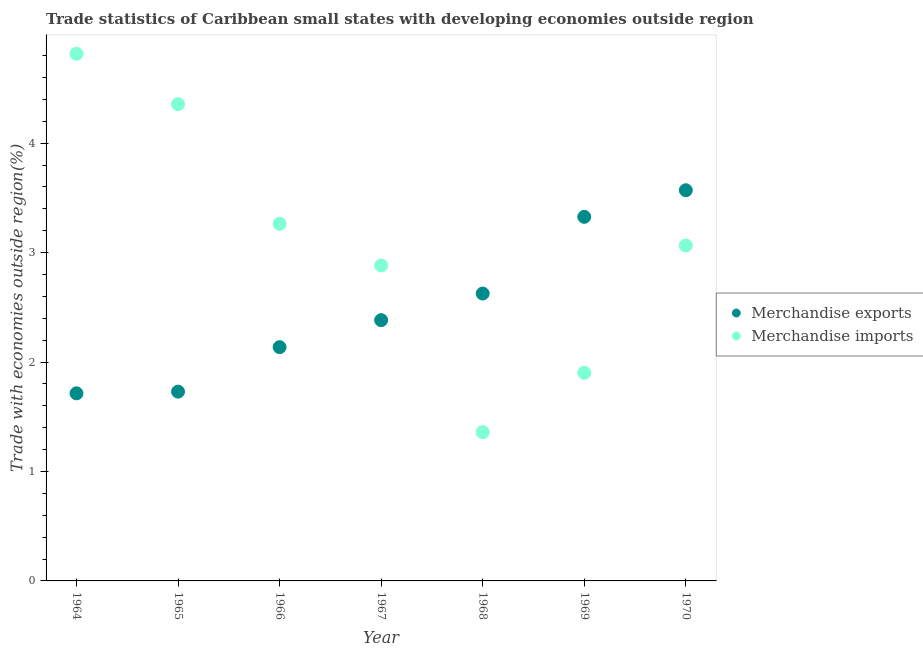Is the number of dotlines equal to the number of legend labels?
Make the answer very short. Yes. What is the merchandise imports in 1968?
Offer a very short reply. 1.36. Across all years, what is the maximum merchandise imports?
Provide a short and direct response. 4.82. Across all years, what is the minimum merchandise exports?
Give a very brief answer. 1.71. In which year was the merchandise imports maximum?
Your answer should be very brief. 1964. In which year was the merchandise exports minimum?
Your answer should be compact. 1964. What is the total merchandise exports in the graph?
Your answer should be compact. 17.49. What is the difference between the merchandise exports in 1968 and that in 1970?
Your answer should be very brief. -0.94. What is the difference between the merchandise imports in 1966 and the merchandise exports in 1970?
Provide a succinct answer. -0.31. What is the average merchandise imports per year?
Give a very brief answer. 3.09. In the year 1966, what is the difference between the merchandise imports and merchandise exports?
Your response must be concise. 1.13. In how many years, is the merchandise imports greater than 2 %?
Keep it short and to the point. 5. What is the ratio of the merchandise imports in 1965 to that in 1966?
Offer a very short reply. 1.33. Is the merchandise exports in 1964 less than that in 1965?
Provide a succinct answer. Yes. What is the difference between the highest and the second highest merchandise exports?
Make the answer very short. 0.24. What is the difference between the highest and the lowest merchandise imports?
Your answer should be very brief. 3.46. In how many years, is the merchandise imports greater than the average merchandise imports taken over all years?
Offer a terse response. 3. Is the sum of the merchandise exports in 1967 and 1969 greater than the maximum merchandise imports across all years?
Provide a short and direct response. Yes. Does the graph contain any zero values?
Keep it short and to the point. No. How are the legend labels stacked?
Ensure brevity in your answer.  Vertical. What is the title of the graph?
Your answer should be very brief. Trade statistics of Caribbean small states with developing economies outside region. Does "Boys" appear as one of the legend labels in the graph?
Ensure brevity in your answer.  No. What is the label or title of the Y-axis?
Offer a very short reply. Trade with economies outside region(%). What is the Trade with economies outside region(%) in Merchandise exports in 1964?
Provide a short and direct response. 1.71. What is the Trade with economies outside region(%) in Merchandise imports in 1964?
Provide a succinct answer. 4.82. What is the Trade with economies outside region(%) in Merchandise exports in 1965?
Provide a succinct answer. 1.73. What is the Trade with economies outside region(%) in Merchandise imports in 1965?
Offer a terse response. 4.36. What is the Trade with economies outside region(%) in Merchandise exports in 1966?
Ensure brevity in your answer.  2.14. What is the Trade with economies outside region(%) of Merchandise imports in 1966?
Your answer should be compact. 3.26. What is the Trade with economies outside region(%) of Merchandise exports in 1967?
Offer a very short reply. 2.38. What is the Trade with economies outside region(%) of Merchandise imports in 1967?
Provide a succinct answer. 2.88. What is the Trade with economies outside region(%) of Merchandise exports in 1968?
Ensure brevity in your answer.  2.63. What is the Trade with economies outside region(%) in Merchandise imports in 1968?
Offer a very short reply. 1.36. What is the Trade with economies outside region(%) of Merchandise exports in 1969?
Provide a succinct answer. 3.33. What is the Trade with economies outside region(%) in Merchandise imports in 1969?
Your response must be concise. 1.9. What is the Trade with economies outside region(%) of Merchandise exports in 1970?
Ensure brevity in your answer.  3.57. What is the Trade with economies outside region(%) in Merchandise imports in 1970?
Offer a very short reply. 3.07. Across all years, what is the maximum Trade with economies outside region(%) of Merchandise exports?
Ensure brevity in your answer.  3.57. Across all years, what is the maximum Trade with economies outside region(%) in Merchandise imports?
Give a very brief answer. 4.82. Across all years, what is the minimum Trade with economies outside region(%) of Merchandise exports?
Make the answer very short. 1.71. Across all years, what is the minimum Trade with economies outside region(%) in Merchandise imports?
Your response must be concise. 1.36. What is the total Trade with economies outside region(%) in Merchandise exports in the graph?
Make the answer very short. 17.49. What is the total Trade with economies outside region(%) of Merchandise imports in the graph?
Your response must be concise. 21.65. What is the difference between the Trade with economies outside region(%) of Merchandise exports in 1964 and that in 1965?
Provide a succinct answer. -0.02. What is the difference between the Trade with economies outside region(%) in Merchandise imports in 1964 and that in 1965?
Make the answer very short. 0.46. What is the difference between the Trade with economies outside region(%) in Merchandise exports in 1964 and that in 1966?
Ensure brevity in your answer.  -0.42. What is the difference between the Trade with economies outside region(%) of Merchandise imports in 1964 and that in 1966?
Offer a very short reply. 1.55. What is the difference between the Trade with economies outside region(%) in Merchandise exports in 1964 and that in 1967?
Offer a very short reply. -0.67. What is the difference between the Trade with economies outside region(%) of Merchandise imports in 1964 and that in 1967?
Your answer should be compact. 1.93. What is the difference between the Trade with economies outside region(%) in Merchandise exports in 1964 and that in 1968?
Your response must be concise. -0.91. What is the difference between the Trade with economies outside region(%) of Merchandise imports in 1964 and that in 1968?
Your answer should be compact. 3.46. What is the difference between the Trade with economies outside region(%) of Merchandise exports in 1964 and that in 1969?
Offer a very short reply. -1.61. What is the difference between the Trade with economies outside region(%) in Merchandise imports in 1964 and that in 1969?
Provide a succinct answer. 2.92. What is the difference between the Trade with economies outside region(%) of Merchandise exports in 1964 and that in 1970?
Keep it short and to the point. -1.86. What is the difference between the Trade with economies outside region(%) of Merchandise imports in 1964 and that in 1970?
Offer a terse response. 1.75. What is the difference between the Trade with economies outside region(%) of Merchandise exports in 1965 and that in 1966?
Make the answer very short. -0.41. What is the difference between the Trade with economies outside region(%) in Merchandise imports in 1965 and that in 1966?
Your answer should be very brief. 1.09. What is the difference between the Trade with economies outside region(%) of Merchandise exports in 1965 and that in 1967?
Provide a succinct answer. -0.65. What is the difference between the Trade with economies outside region(%) in Merchandise imports in 1965 and that in 1967?
Your response must be concise. 1.47. What is the difference between the Trade with economies outside region(%) in Merchandise exports in 1965 and that in 1968?
Ensure brevity in your answer.  -0.9. What is the difference between the Trade with economies outside region(%) of Merchandise imports in 1965 and that in 1968?
Offer a very short reply. 3. What is the difference between the Trade with economies outside region(%) in Merchandise exports in 1965 and that in 1969?
Make the answer very short. -1.6. What is the difference between the Trade with economies outside region(%) in Merchandise imports in 1965 and that in 1969?
Give a very brief answer. 2.45. What is the difference between the Trade with economies outside region(%) of Merchandise exports in 1965 and that in 1970?
Keep it short and to the point. -1.84. What is the difference between the Trade with economies outside region(%) of Merchandise imports in 1965 and that in 1970?
Your answer should be compact. 1.29. What is the difference between the Trade with economies outside region(%) of Merchandise exports in 1966 and that in 1967?
Provide a succinct answer. -0.25. What is the difference between the Trade with economies outside region(%) in Merchandise imports in 1966 and that in 1967?
Give a very brief answer. 0.38. What is the difference between the Trade with economies outside region(%) in Merchandise exports in 1966 and that in 1968?
Your answer should be very brief. -0.49. What is the difference between the Trade with economies outside region(%) of Merchandise imports in 1966 and that in 1968?
Provide a short and direct response. 1.9. What is the difference between the Trade with economies outside region(%) of Merchandise exports in 1966 and that in 1969?
Your response must be concise. -1.19. What is the difference between the Trade with economies outside region(%) of Merchandise imports in 1966 and that in 1969?
Make the answer very short. 1.36. What is the difference between the Trade with economies outside region(%) of Merchandise exports in 1966 and that in 1970?
Offer a very short reply. -1.43. What is the difference between the Trade with economies outside region(%) in Merchandise imports in 1966 and that in 1970?
Ensure brevity in your answer.  0.2. What is the difference between the Trade with economies outside region(%) of Merchandise exports in 1967 and that in 1968?
Your response must be concise. -0.24. What is the difference between the Trade with economies outside region(%) of Merchandise imports in 1967 and that in 1968?
Provide a succinct answer. 1.52. What is the difference between the Trade with economies outside region(%) of Merchandise exports in 1967 and that in 1969?
Your answer should be very brief. -0.94. What is the difference between the Trade with economies outside region(%) of Merchandise imports in 1967 and that in 1969?
Your answer should be compact. 0.98. What is the difference between the Trade with economies outside region(%) in Merchandise exports in 1967 and that in 1970?
Your response must be concise. -1.19. What is the difference between the Trade with economies outside region(%) of Merchandise imports in 1967 and that in 1970?
Provide a short and direct response. -0.18. What is the difference between the Trade with economies outside region(%) of Merchandise exports in 1968 and that in 1969?
Make the answer very short. -0.7. What is the difference between the Trade with economies outside region(%) of Merchandise imports in 1968 and that in 1969?
Your answer should be very brief. -0.54. What is the difference between the Trade with economies outside region(%) of Merchandise exports in 1968 and that in 1970?
Make the answer very short. -0.94. What is the difference between the Trade with economies outside region(%) in Merchandise imports in 1968 and that in 1970?
Provide a short and direct response. -1.71. What is the difference between the Trade with economies outside region(%) of Merchandise exports in 1969 and that in 1970?
Your answer should be compact. -0.24. What is the difference between the Trade with economies outside region(%) in Merchandise imports in 1969 and that in 1970?
Ensure brevity in your answer.  -1.16. What is the difference between the Trade with economies outside region(%) in Merchandise exports in 1964 and the Trade with economies outside region(%) in Merchandise imports in 1965?
Your response must be concise. -2.64. What is the difference between the Trade with economies outside region(%) of Merchandise exports in 1964 and the Trade with economies outside region(%) of Merchandise imports in 1966?
Your answer should be very brief. -1.55. What is the difference between the Trade with economies outside region(%) in Merchandise exports in 1964 and the Trade with economies outside region(%) in Merchandise imports in 1967?
Keep it short and to the point. -1.17. What is the difference between the Trade with economies outside region(%) in Merchandise exports in 1964 and the Trade with economies outside region(%) in Merchandise imports in 1968?
Provide a short and direct response. 0.35. What is the difference between the Trade with economies outside region(%) in Merchandise exports in 1964 and the Trade with economies outside region(%) in Merchandise imports in 1969?
Provide a short and direct response. -0.19. What is the difference between the Trade with economies outside region(%) in Merchandise exports in 1964 and the Trade with economies outside region(%) in Merchandise imports in 1970?
Keep it short and to the point. -1.35. What is the difference between the Trade with economies outside region(%) in Merchandise exports in 1965 and the Trade with economies outside region(%) in Merchandise imports in 1966?
Your answer should be compact. -1.53. What is the difference between the Trade with economies outside region(%) in Merchandise exports in 1965 and the Trade with economies outside region(%) in Merchandise imports in 1967?
Ensure brevity in your answer.  -1.15. What is the difference between the Trade with economies outside region(%) in Merchandise exports in 1965 and the Trade with economies outside region(%) in Merchandise imports in 1968?
Ensure brevity in your answer.  0.37. What is the difference between the Trade with economies outside region(%) of Merchandise exports in 1965 and the Trade with economies outside region(%) of Merchandise imports in 1969?
Your answer should be very brief. -0.17. What is the difference between the Trade with economies outside region(%) in Merchandise exports in 1965 and the Trade with economies outside region(%) in Merchandise imports in 1970?
Give a very brief answer. -1.34. What is the difference between the Trade with economies outside region(%) of Merchandise exports in 1966 and the Trade with economies outside region(%) of Merchandise imports in 1967?
Keep it short and to the point. -0.75. What is the difference between the Trade with economies outside region(%) of Merchandise exports in 1966 and the Trade with economies outside region(%) of Merchandise imports in 1968?
Your answer should be compact. 0.78. What is the difference between the Trade with economies outside region(%) in Merchandise exports in 1966 and the Trade with economies outside region(%) in Merchandise imports in 1969?
Ensure brevity in your answer.  0.23. What is the difference between the Trade with economies outside region(%) in Merchandise exports in 1966 and the Trade with economies outside region(%) in Merchandise imports in 1970?
Provide a short and direct response. -0.93. What is the difference between the Trade with economies outside region(%) of Merchandise exports in 1967 and the Trade with economies outside region(%) of Merchandise imports in 1968?
Offer a terse response. 1.02. What is the difference between the Trade with economies outside region(%) of Merchandise exports in 1967 and the Trade with economies outside region(%) of Merchandise imports in 1969?
Ensure brevity in your answer.  0.48. What is the difference between the Trade with economies outside region(%) in Merchandise exports in 1967 and the Trade with economies outside region(%) in Merchandise imports in 1970?
Your answer should be very brief. -0.68. What is the difference between the Trade with economies outside region(%) in Merchandise exports in 1968 and the Trade with economies outside region(%) in Merchandise imports in 1969?
Your answer should be compact. 0.72. What is the difference between the Trade with economies outside region(%) of Merchandise exports in 1968 and the Trade with economies outside region(%) of Merchandise imports in 1970?
Give a very brief answer. -0.44. What is the difference between the Trade with economies outside region(%) of Merchandise exports in 1969 and the Trade with economies outside region(%) of Merchandise imports in 1970?
Keep it short and to the point. 0.26. What is the average Trade with economies outside region(%) in Merchandise exports per year?
Make the answer very short. 2.5. What is the average Trade with economies outside region(%) of Merchandise imports per year?
Give a very brief answer. 3.09. In the year 1964, what is the difference between the Trade with economies outside region(%) in Merchandise exports and Trade with economies outside region(%) in Merchandise imports?
Your answer should be very brief. -3.1. In the year 1965, what is the difference between the Trade with economies outside region(%) of Merchandise exports and Trade with economies outside region(%) of Merchandise imports?
Keep it short and to the point. -2.63. In the year 1966, what is the difference between the Trade with economies outside region(%) of Merchandise exports and Trade with economies outside region(%) of Merchandise imports?
Ensure brevity in your answer.  -1.13. In the year 1967, what is the difference between the Trade with economies outside region(%) in Merchandise exports and Trade with economies outside region(%) in Merchandise imports?
Provide a short and direct response. -0.5. In the year 1968, what is the difference between the Trade with economies outside region(%) in Merchandise exports and Trade with economies outside region(%) in Merchandise imports?
Your response must be concise. 1.27. In the year 1969, what is the difference between the Trade with economies outside region(%) of Merchandise exports and Trade with economies outside region(%) of Merchandise imports?
Your answer should be very brief. 1.43. In the year 1970, what is the difference between the Trade with economies outside region(%) of Merchandise exports and Trade with economies outside region(%) of Merchandise imports?
Provide a short and direct response. 0.5. What is the ratio of the Trade with economies outside region(%) in Merchandise exports in 1964 to that in 1965?
Your answer should be compact. 0.99. What is the ratio of the Trade with economies outside region(%) in Merchandise imports in 1964 to that in 1965?
Give a very brief answer. 1.11. What is the ratio of the Trade with economies outside region(%) in Merchandise exports in 1964 to that in 1966?
Offer a very short reply. 0.8. What is the ratio of the Trade with economies outside region(%) in Merchandise imports in 1964 to that in 1966?
Your answer should be compact. 1.48. What is the ratio of the Trade with economies outside region(%) of Merchandise exports in 1964 to that in 1967?
Offer a terse response. 0.72. What is the ratio of the Trade with economies outside region(%) in Merchandise imports in 1964 to that in 1967?
Offer a very short reply. 1.67. What is the ratio of the Trade with economies outside region(%) of Merchandise exports in 1964 to that in 1968?
Provide a short and direct response. 0.65. What is the ratio of the Trade with economies outside region(%) of Merchandise imports in 1964 to that in 1968?
Your answer should be compact. 3.54. What is the ratio of the Trade with economies outside region(%) in Merchandise exports in 1964 to that in 1969?
Your answer should be very brief. 0.52. What is the ratio of the Trade with economies outside region(%) in Merchandise imports in 1964 to that in 1969?
Your response must be concise. 2.53. What is the ratio of the Trade with economies outside region(%) in Merchandise exports in 1964 to that in 1970?
Make the answer very short. 0.48. What is the ratio of the Trade with economies outside region(%) of Merchandise imports in 1964 to that in 1970?
Your answer should be compact. 1.57. What is the ratio of the Trade with economies outside region(%) in Merchandise exports in 1965 to that in 1966?
Provide a short and direct response. 0.81. What is the ratio of the Trade with economies outside region(%) of Merchandise imports in 1965 to that in 1966?
Keep it short and to the point. 1.33. What is the ratio of the Trade with economies outside region(%) in Merchandise exports in 1965 to that in 1967?
Your answer should be compact. 0.73. What is the ratio of the Trade with economies outside region(%) in Merchandise imports in 1965 to that in 1967?
Give a very brief answer. 1.51. What is the ratio of the Trade with economies outside region(%) of Merchandise exports in 1965 to that in 1968?
Your answer should be compact. 0.66. What is the ratio of the Trade with economies outside region(%) in Merchandise imports in 1965 to that in 1968?
Your answer should be compact. 3.2. What is the ratio of the Trade with economies outside region(%) in Merchandise exports in 1965 to that in 1969?
Give a very brief answer. 0.52. What is the ratio of the Trade with economies outside region(%) of Merchandise imports in 1965 to that in 1969?
Your response must be concise. 2.29. What is the ratio of the Trade with economies outside region(%) in Merchandise exports in 1965 to that in 1970?
Provide a succinct answer. 0.48. What is the ratio of the Trade with economies outside region(%) in Merchandise imports in 1965 to that in 1970?
Ensure brevity in your answer.  1.42. What is the ratio of the Trade with economies outside region(%) in Merchandise exports in 1966 to that in 1967?
Provide a succinct answer. 0.9. What is the ratio of the Trade with economies outside region(%) of Merchandise imports in 1966 to that in 1967?
Offer a very short reply. 1.13. What is the ratio of the Trade with economies outside region(%) of Merchandise exports in 1966 to that in 1968?
Offer a terse response. 0.81. What is the ratio of the Trade with economies outside region(%) of Merchandise imports in 1966 to that in 1968?
Provide a succinct answer. 2.4. What is the ratio of the Trade with economies outside region(%) of Merchandise exports in 1966 to that in 1969?
Ensure brevity in your answer.  0.64. What is the ratio of the Trade with economies outside region(%) in Merchandise imports in 1966 to that in 1969?
Your answer should be very brief. 1.72. What is the ratio of the Trade with economies outside region(%) of Merchandise exports in 1966 to that in 1970?
Ensure brevity in your answer.  0.6. What is the ratio of the Trade with economies outside region(%) of Merchandise imports in 1966 to that in 1970?
Provide a succinct answer. 1.06. What is the ratio of the Trade with economies outside region(%) of Merchandise exports in 1967 to that in 1968?
Offer a terse response. 0.91. What is the ratio of the Trade with economies outside region(%) in Merchandise imports in 1967 to that in 1968?
Give a very brief answer. 2.12. What is the ratio of the Trade with economies outside region(%) of Merchandise exports in 1967 to that in 1969?
Your answer should be very brief. 0.72. What is the ratio of the Trade with economies outside region(%) of Merchandise imports in 1967 to that in 1969?
Keep it short and to the point. 1.52. What is the ratio of the Trade with economies outside region(%) of Merchandise exports in 1967 to that in 1970?
Your answer should be compact. 0.67. What is the ratio of the Trade with economies outside region(%) in Merchandise imports in 1967 to that in 1970?
Ensure brevity in your answer.  0.94. What is the ratio of the Trade with economies outside region(%) in Merchandise exports in 1968 to that in 1969?
Keep it short and to the point. 0.79. What is the ratio of the Trade with economies outside region(%) of Merchandise imports in 1968 to that in 1969?
Provide a short and direct response. 0.71. What is the ratio of the Trade with economies outside region(%) in Merchandise exports in 1968 to that in 1970?
Make the answer very short. 0.74. What is the ratio of the Trade with economies outside region(%) in Merchandise imports in 1968 to that in 1970?
Provide a succinct answer. 0.44. What is the ratio of the Trade with economies outside region(%) in Merchandise exports in 1969 to that in 1970?
Provide a short and direct response. 0.93. What is the ratio of the Trade with economies outside region(%) in Merchandise imports in 1969 to that in 1970?
Your answer should be very brief. 0.62. What is the difference between the highest and the second highest Trade with economies outside region(%) in Merchandise exports?
Offer a very short reply. 0.24. What is the difference between the highest and the second highest Trade with economies outside region(%) in Merchandise imports?
Ensure brevity in your answer.  0.46. What is the difference between the highest and the lowest Trade with economies outside region(%) in Merchandise exports?
Your response must be concise. 1.86. What is the difference between the highest and the lowest Trade with economies outside region(%) of Merchandise imports?
Your answer should be very brief. 3.46. 